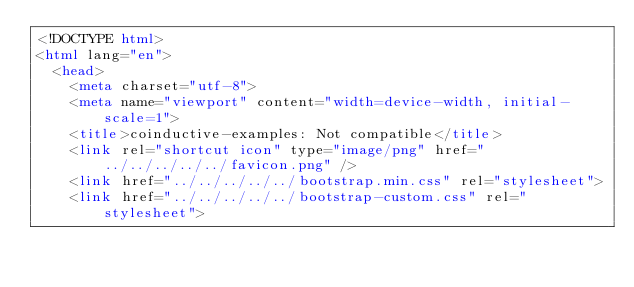Convert code to text. <code><loc_0><loc_0><loc_500><loc_500><_HTML_><!DOCTYPE html>
<html lang="en">
  <head>
    <meta charset="utf-8">
    <meta name="viewport" content="width=device-width, initial-scale=1">
    <title>coinductive-examples: Not compatible</title>
    <link rel="shortcut icon" type="image/png" href="../../../../../favicon.png" />
    <link href="../../../../../bootstrap.min.css" rel="stylesheet">
    <link href="../../../../../bootstrap-custom.css" rel="stylesheet"></code> 